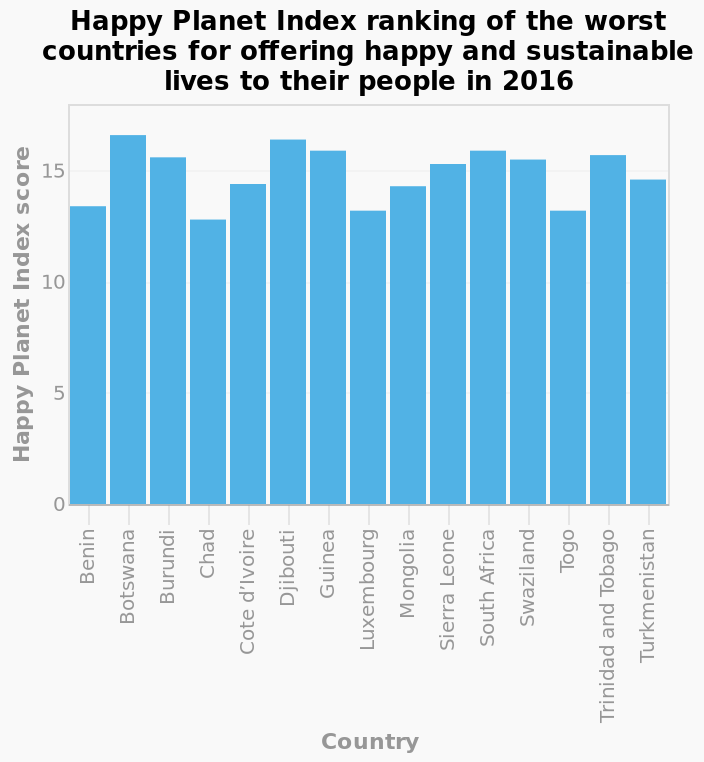<image>
What does the x-axis represent? The x-axis represents the countries. Which country ranked the lowest in offering happy and sustainable lives to their people in 2016 among the 15 countries shown in the graph? Chad was the lowest ranked country. 